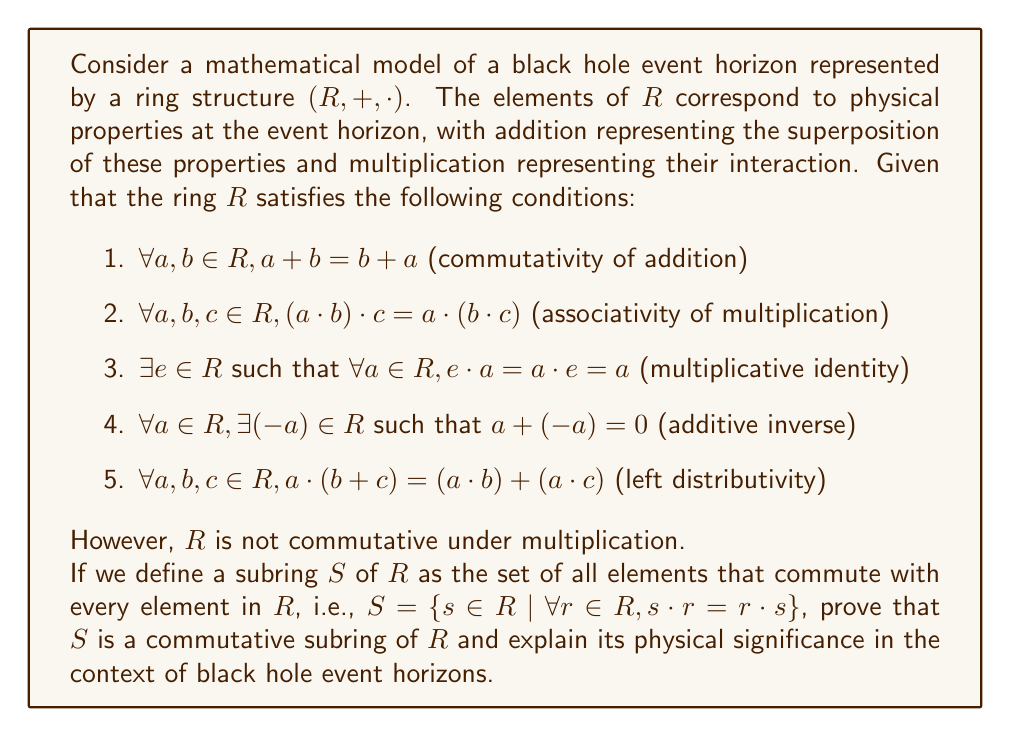Teach me how to tackle this problem. To prove that $S$ is a commutative subring of $R$, we need to show that it is closed under addition and multiplication, contains the additive and multiplicative identities, and is commutative under multiplication. Let's proceed step by step:

1. Closure under addition:
Let $s_1, s_2 \in S$. We need to show that $s_1 + s_2 \in S$.
For any $r \in R$:
$$(s_1 + s_2) \cdot r = s_1 \cdot r + s_2 \cdot r = r \cdot s_1 + r \cdot s_2 = r \cdot (s_1 + s_2)$$
Thus, $s_1 + s_2 \in S$.

2. Closure under multiplication:
Let $s_1, s_2 \in S$. We need to show that $s_1 \cdot s_2 \in S$.
For any $r \in R$:
$$(s_1 \cdot s_2) \cdot r = s_1 \cdot (s_2 \cdot r) = s_1 \cdot (r \cdot s_2) = (s_1 \cdot r) \cdot s_2 = (r \cdot s_1) \cdot s_2 = r \cdot (s_1 \cdot s_2)$$
Thus, $s_1 \cdot s_2 \in S$.

3. Additive identity:
The additive identity $0 \in S$ because $0 \cdot r = 0 = r \cdot 0$ for all $r \in R$.

4. Multiplicative identity:
The multiplicative identity $e \in S$ because $e \cdot r = r = r \cdot e$ for all $r \in R$.

5. Additive inverses:
If $s \in S$, then $-s \in S$ because for any $r \in R$:
$$(-s) \cdot r = -(s \cdot r) = -(r \cdot s) = r \cdot (-s)$$

6. Commutativity of multiplication:
Let $s_1, s_2 \in S$. Then:
$$s_1 \cdot s_2 = s_2 \cdot s_1$$
This is true because $s_1$ commutes with all elements in $R$, including $s_2$.

Therefore, $S$ is a commutative subring of $R$.

Physical significance:
In the context of black hole event horizons, the ring $R$ represents the complex interplay of physical properties at the event horizon. The non-commutativity of multiplication in $R$ could represent the irreversibility and asymmetry of processes near the event horizon due to extreme gravitational effects.

The commutative subring $S$ represents a subset of properties or processes that behave more "classically" or symmetrically at the event horizon. These could correspond to conserved quantities or symmetries that persist even in the extreme conditions near a black hole. For example, quantities related to the black hole's mass, angular momentum, or charge might belong to this subring, as they often commute with other observables in quantum gravity theories.

The existence of this commutative subring suggests that even in the complex and exotic environment of a black hole event horizon, there are still some properties that maintain a degree of symmetry and predictability, providing a bridge between classical and quantum descriptions of black hole physics.
Answer: $S$ is a commutative subring of $R$, representing physical properties or processes at the black hole event horizon that maintain symmetry and commutativity, potentially corresponding to conserved quantities or fundamental symmetries in extreme gravitational conditions. 